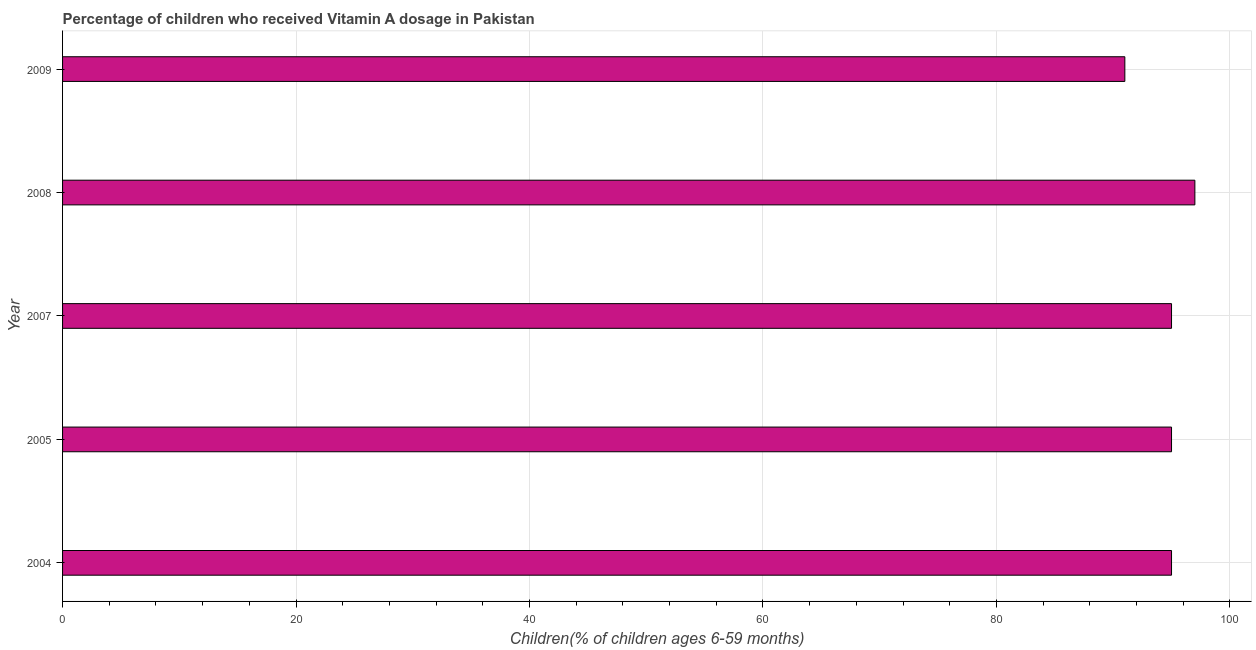Does the graph contain any zero values?
Your answer should be compact. No. What is the title of the graph?
Your answer should be very brief. Percentage of children who received Vitamin A dosage in Pakistan. What is the label or title of the X-axis?
Your answer should be compact. Children(% of children ages 6-59 months). What is the label or title of the Y-axis?
Offer a terse response. Year. What is the vitamin a supplementation coverage rate in 2005?
Provide a succinct answer. 95. Across all years, what is the maximum vitamin a supplementation coverage rate?
Give a very brief answer. 97. Across all years, what is the minimum vitamin a supplementation coverage rate?
Make the answer very short. 91. What is the sum of the vitamin a supplementation coverage rate?
Your answer should be compact. 473. What is the difference between the vitamin a supplementation coverage rate in 2004 and 2007?
Ensure brevity in your answer.  0. What is the average vitamin a supplementation coverage rate per year?
Keep it short and to the point. 94. Is the vitamin a supplementation coverage rate in 2008 less than that in 2009?
Your response must be concise. No. Is the difference between the vitamin a supplementation coverage rate in 2005 and 2008 greater than the difference between any two years?
Your answer should be compact. No. What is the difference between two consecutive major ticks on the X-axis?
Keep it short and to the point. 20. What is the Children(% of children ages 6-59 months) of 2004?
Provide a short and direct response. 95. What is the Children(% of children ages 6-59 months) in 2005?
Offer a terse response. 95. What is the Children(% of children ages 6-59 months) in 2007?
Provide a short and direct response. 95. What is the Children(% of children ages 6-59 months) in 2008?
Make the answer very short. 97. What is the Children(% of children ages 6-59 months) in 2009?
Offer a very short reply. 91. What is the difference between the Children(% of children ages 6-59 months) in 2004 and 2007?
Provide a succinct answer. 0. What is the difference between the Children(% of children ages 6-59 months) in 2004 and 2009?
Keep it short and to the point. 4. What is the difference between the Children(% of children ages 6-59 months) in 2005 and 2007?
Provide a short and direct response. 0. What is the difference between the Children(% of children ages 6-59 months) in 2005 and 2008?
Ensure brevity in your answer.  -2. What is the difference between the Children(% of children ages 6-59 months) in 2007 and 2008?
Your answer should be compact. -2. What is the difference between the Children(% of children ages 6-59 months) in 2007 and 2009?
Your answer should be compact. 4. What is the difference between the Children(% of children ages 6-59 months) in 2008 and 2009?
Give a very brief answer. 6. What is the ratio of the Children(% of children ages 6-59 months) in 2004 to that in 2009?
Provide a short and direct response. 1.04. What is the ratio of the Children(% of children ages 6-59 months) in 2005 to that in 2007?
Offer a terse response. 1. What is the ratio of the Children(% of children ages 6-59 months) in 2005 to that in 2009?
Provide a short and direct response. 1.04. What is the ratio of the Children(% of children ages 6-59 months) in 2007 to that in 2008?
Keep it short and to the point. 0.98. What is the ratio of the Children(% of children ages 6-59 months) in 2007 to that in 2009?
Provide a short and direct response. 1.04. What is the ratio of the Children(% of children ages 6-59 months) in 2008 to that in 2009?
Your response must be concise. 1.07. 